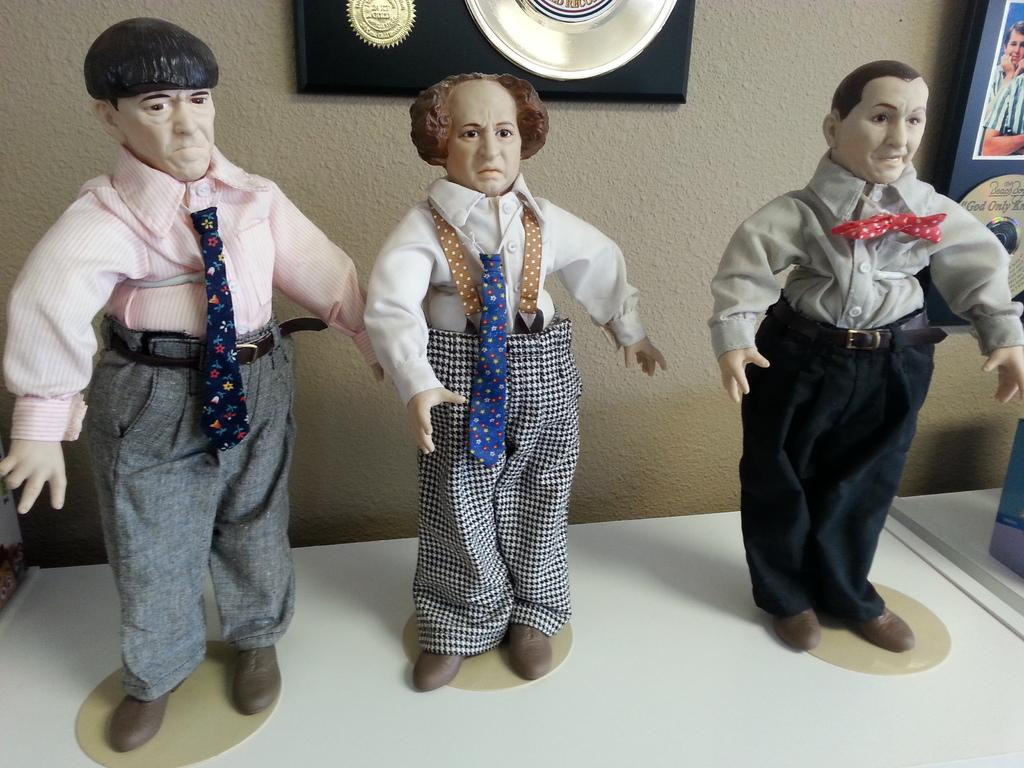What type of objects can be seen on the table in the image? There are toys on the table in the image. What can be found on the wall in the image? There are frames on the wall in the image. Can you describe the object on the table? There is an object on the table, but its specific details are not mentioned in the provided facts. What type of competition is taking place in the image? There is no competition present in the image. Can you tell me how many cows are visible in the image? There are no cows present in the image. 